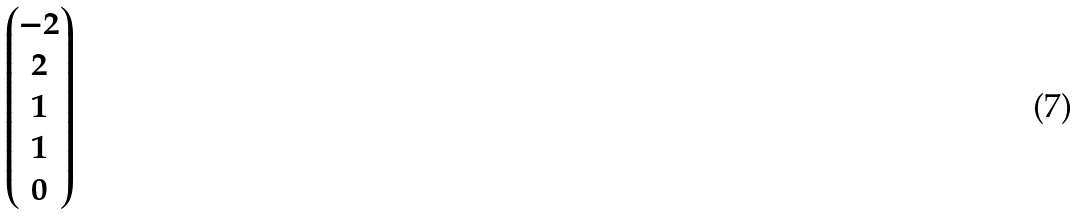<formula> <loc_0><loc_0><loc_500><loc_500>\begin{pmatrix} - 2 \\ 2 \\ 1 \\ 1 \\ 0 \end{pmatrix}</formula> 